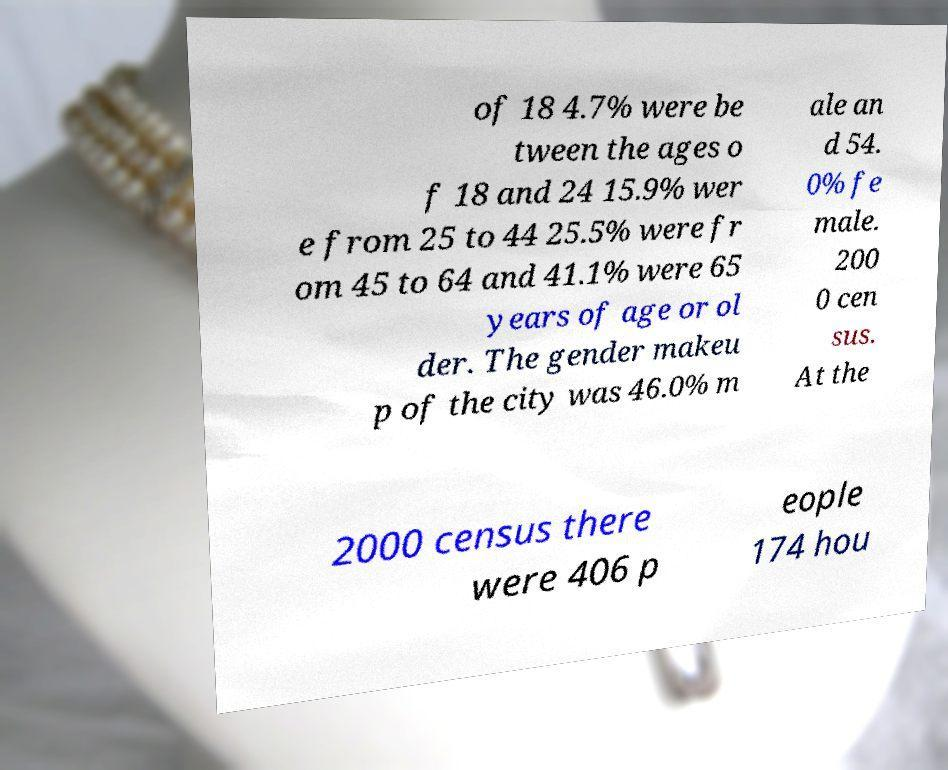There's text embedded in this image that I need extracted. Can you transcribe it verbatim? of 18 4.7% were be tween the ages o f 18 and 24 15.9% wer e from 25 to 44 25.5% were fr om 45 to 64 and 41.1% were 65 years of age or ol der. The gender makeu p of the city was 46.0% m ale an d 54. 0% fe male. 200 0 cen sus. At the 2000 census there were 406 p eople 174 hou 